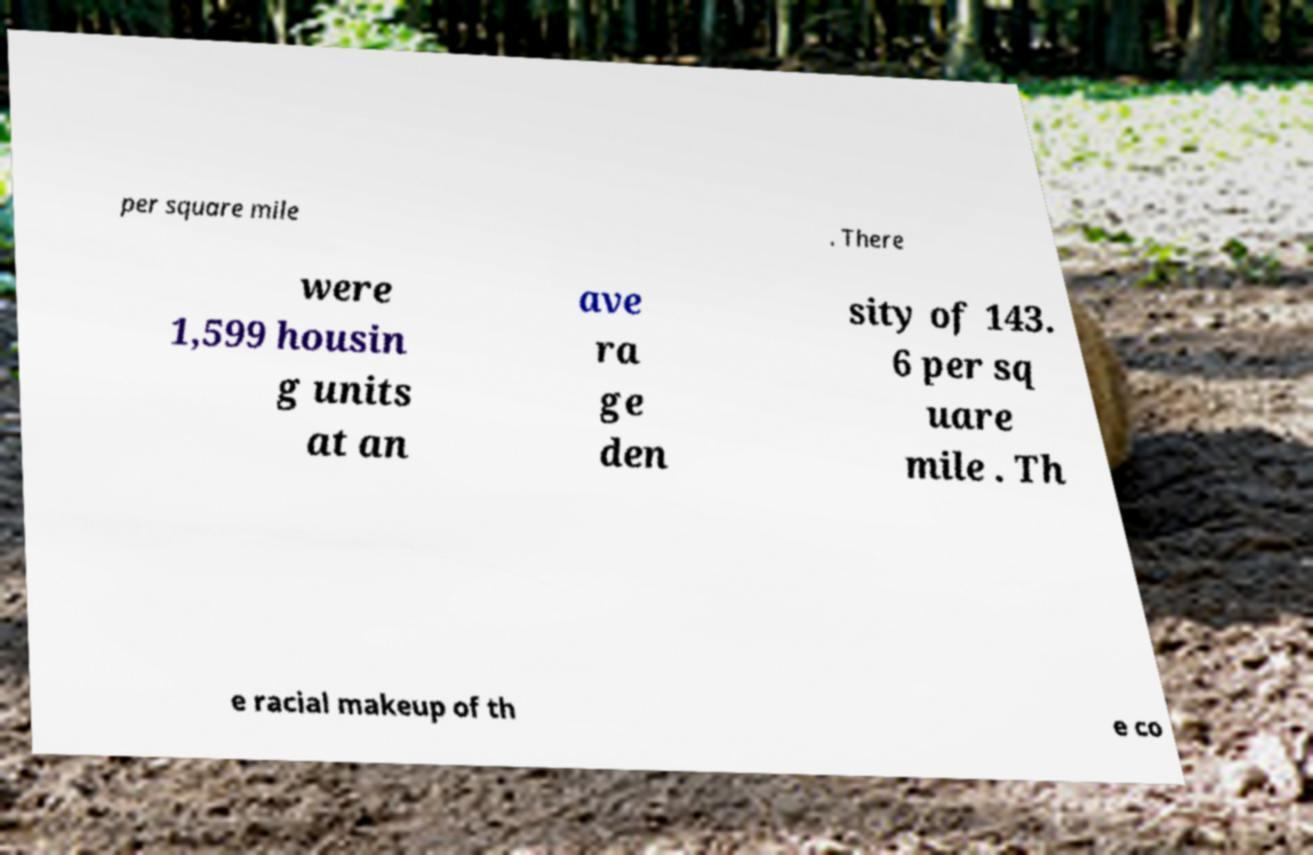I need the written content from this picture converted into text. Can you do that? per square mile . There were 1,599 housin g units at an ave ra ge den sity of 143. 6 per sq uare mile . Th e racial makeup of th e co 